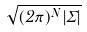<formula> <loc_0><loc_0><loc_500><loc_500>\sqrt { ( 2 \pi ) ^ { N } | \Sigma | }</formula> 